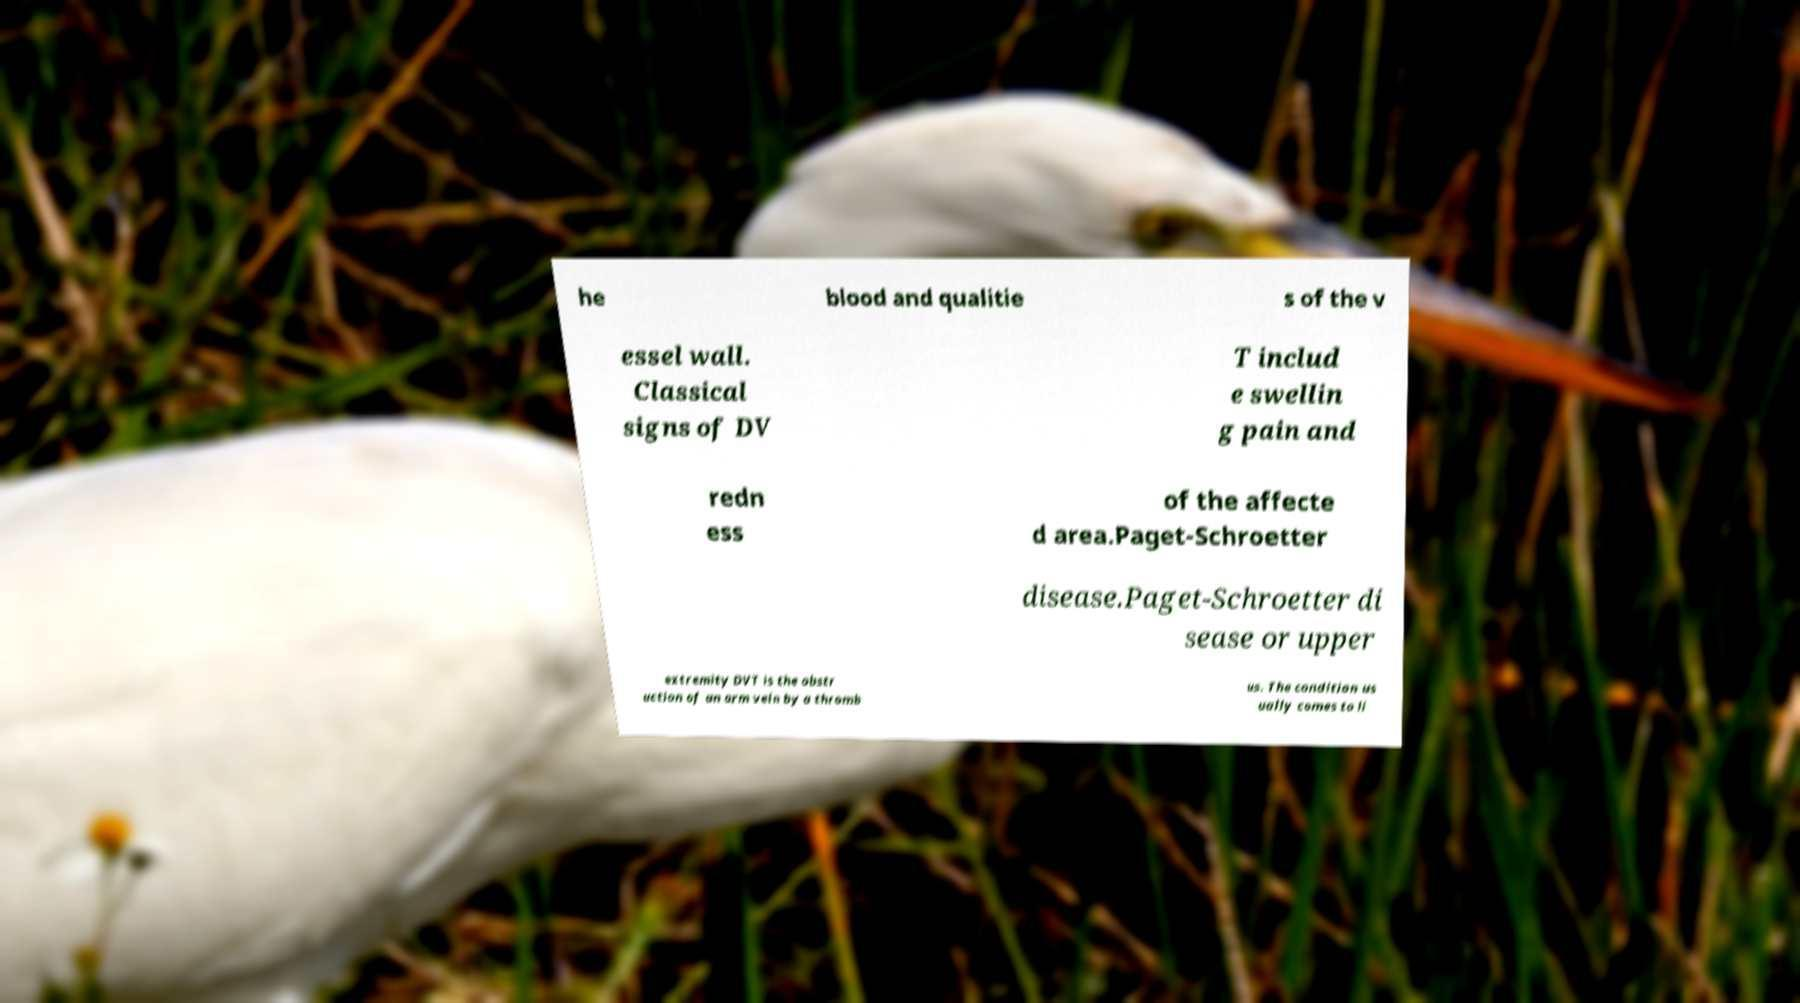Could you extract and type out the text from this image? he blood and qualitie s of the v essel wall. Classical signs of DV T includ e swellin g pain and redn ess of the affecte d area.Paget-Schroetter disease.Paget-Schroetter di sease or upper extremity DVT is the obstr uction of an arm vein by a thromb us. The condition us ually comes to li 